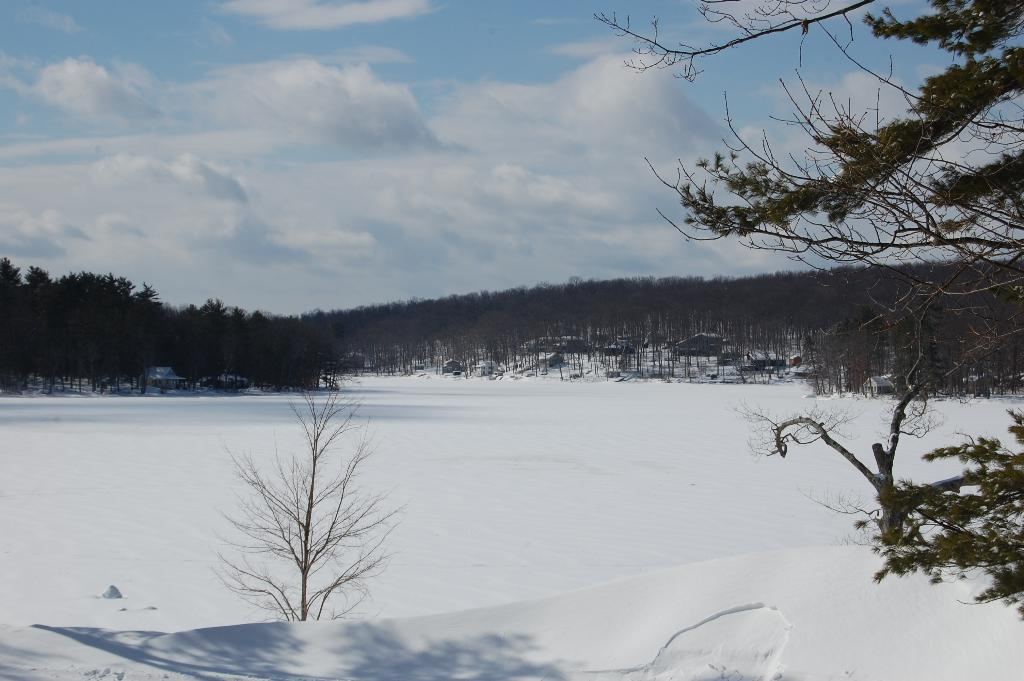What is the primary element that makes up the image? The image consists of snow. What can be seen in the background of the image? There are trees in the background of the image. What is visible in the sky at the top of the image? There are clouds visible in the sky at the top of the image. Where is the map located in the image? There is no map present in the image; it consists of snow, trees, and clouds. What type of ornament can be seen hanging from the trees in the image? There are no ornaments present in the image; it consists of snow, trees, and clouds. 